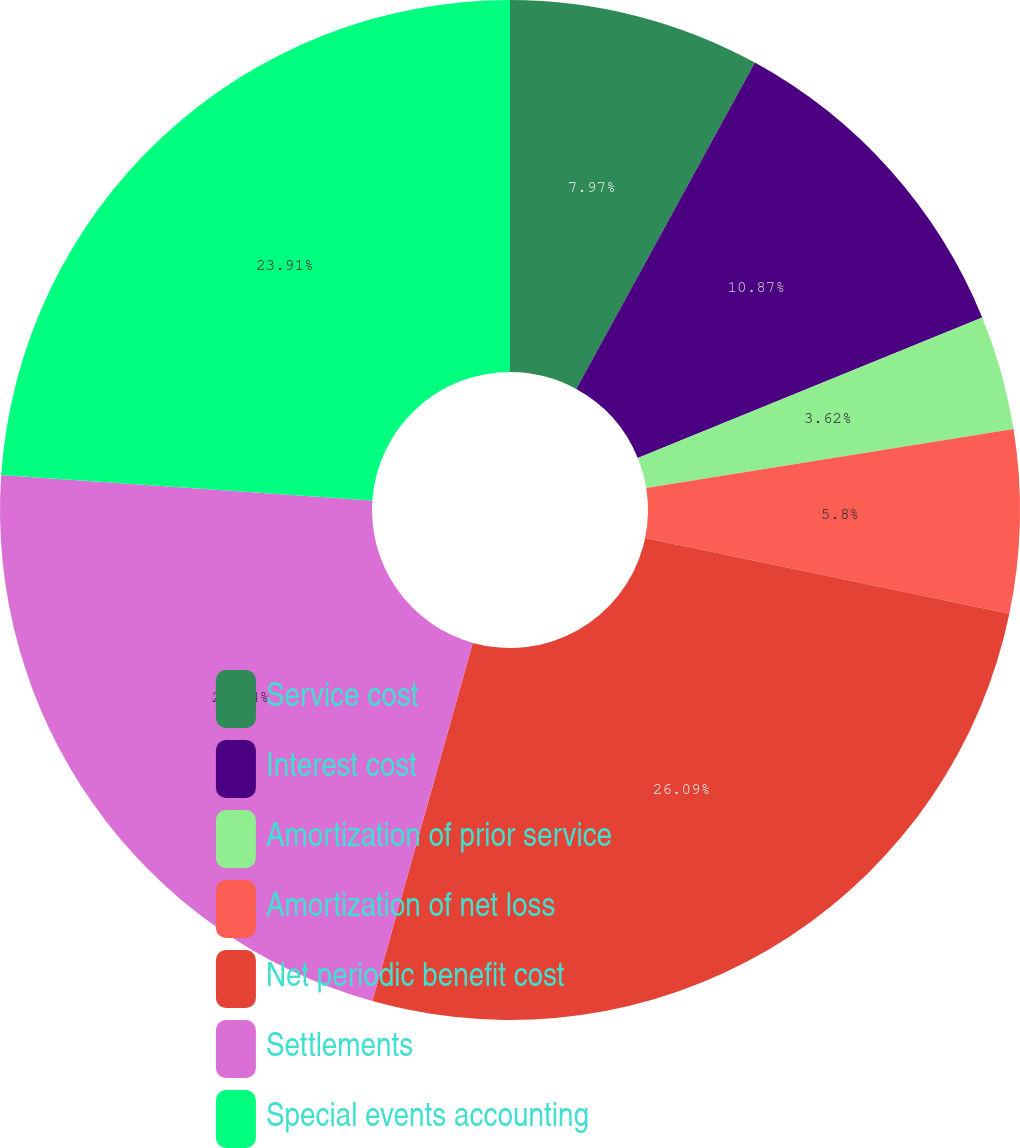Convert chart. <chart><loc_0><loc_0><loc_500><loc_500><pie_chart><fcel>Service cost<fcel>Interest cost<fcel>Amortization of prior service<fcel>Amortization of net loss<fcel>Net periodic benefit cost<fcel>Settlements<fcel>Special events accounting<nl><fcel>7.97%<fcel>10.87%<fcel>3.62%<fcel>5.8%<fcel>26.09%<fcel>21.74%<fcel>23.91%<nl></chart> 